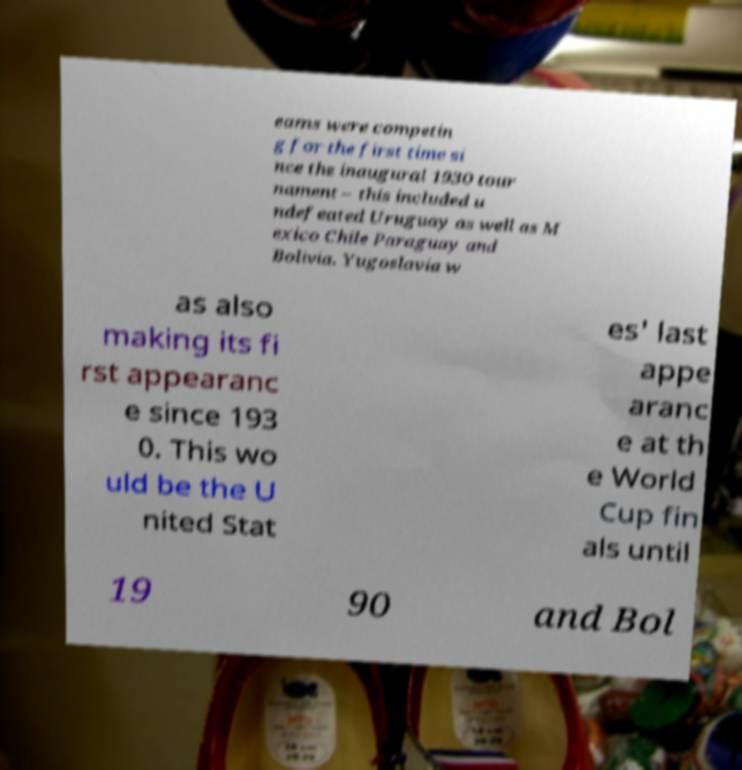Can you accurately transcribe the text from the provided image for me? eams were competin g for the first time si nce the inaugural 1930 tour nament – this included u ndefeated Uruguay as well as M exico Chile Paraguay and Bolivia. Yugoslavia w as also making its fi rst appearanc e since 193 0. This wo uld be the U nited Stat es' last appe aranc e at th e World Cup fin als until 19 90 and Bol 